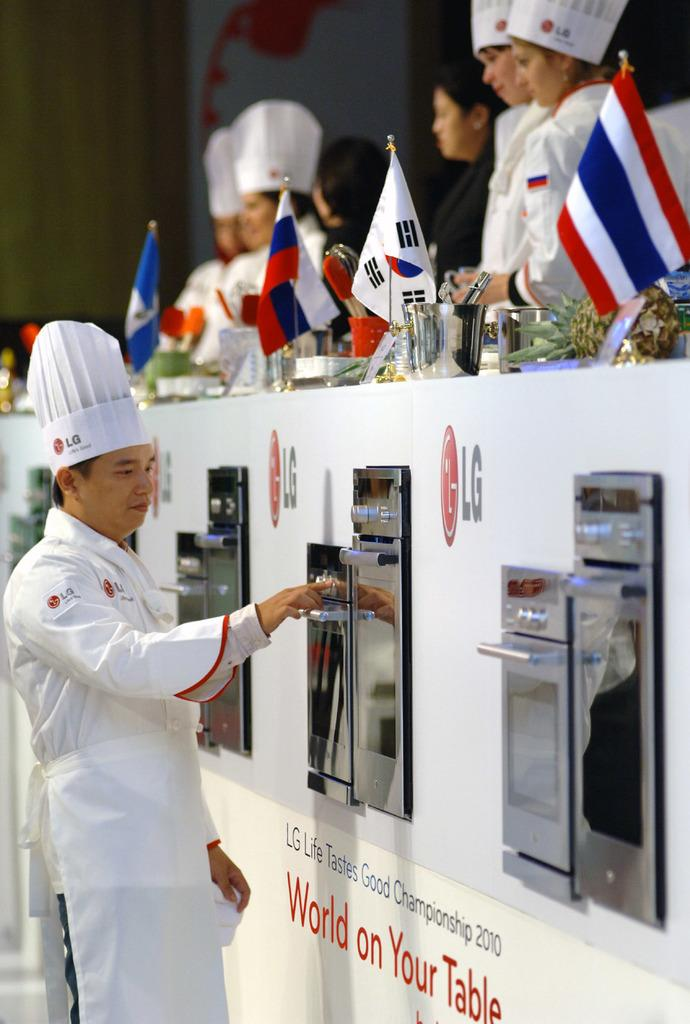Provide a one-sentence caption for the provided image. Several people are at he LG Life Tastes Good Championship in 2010. 